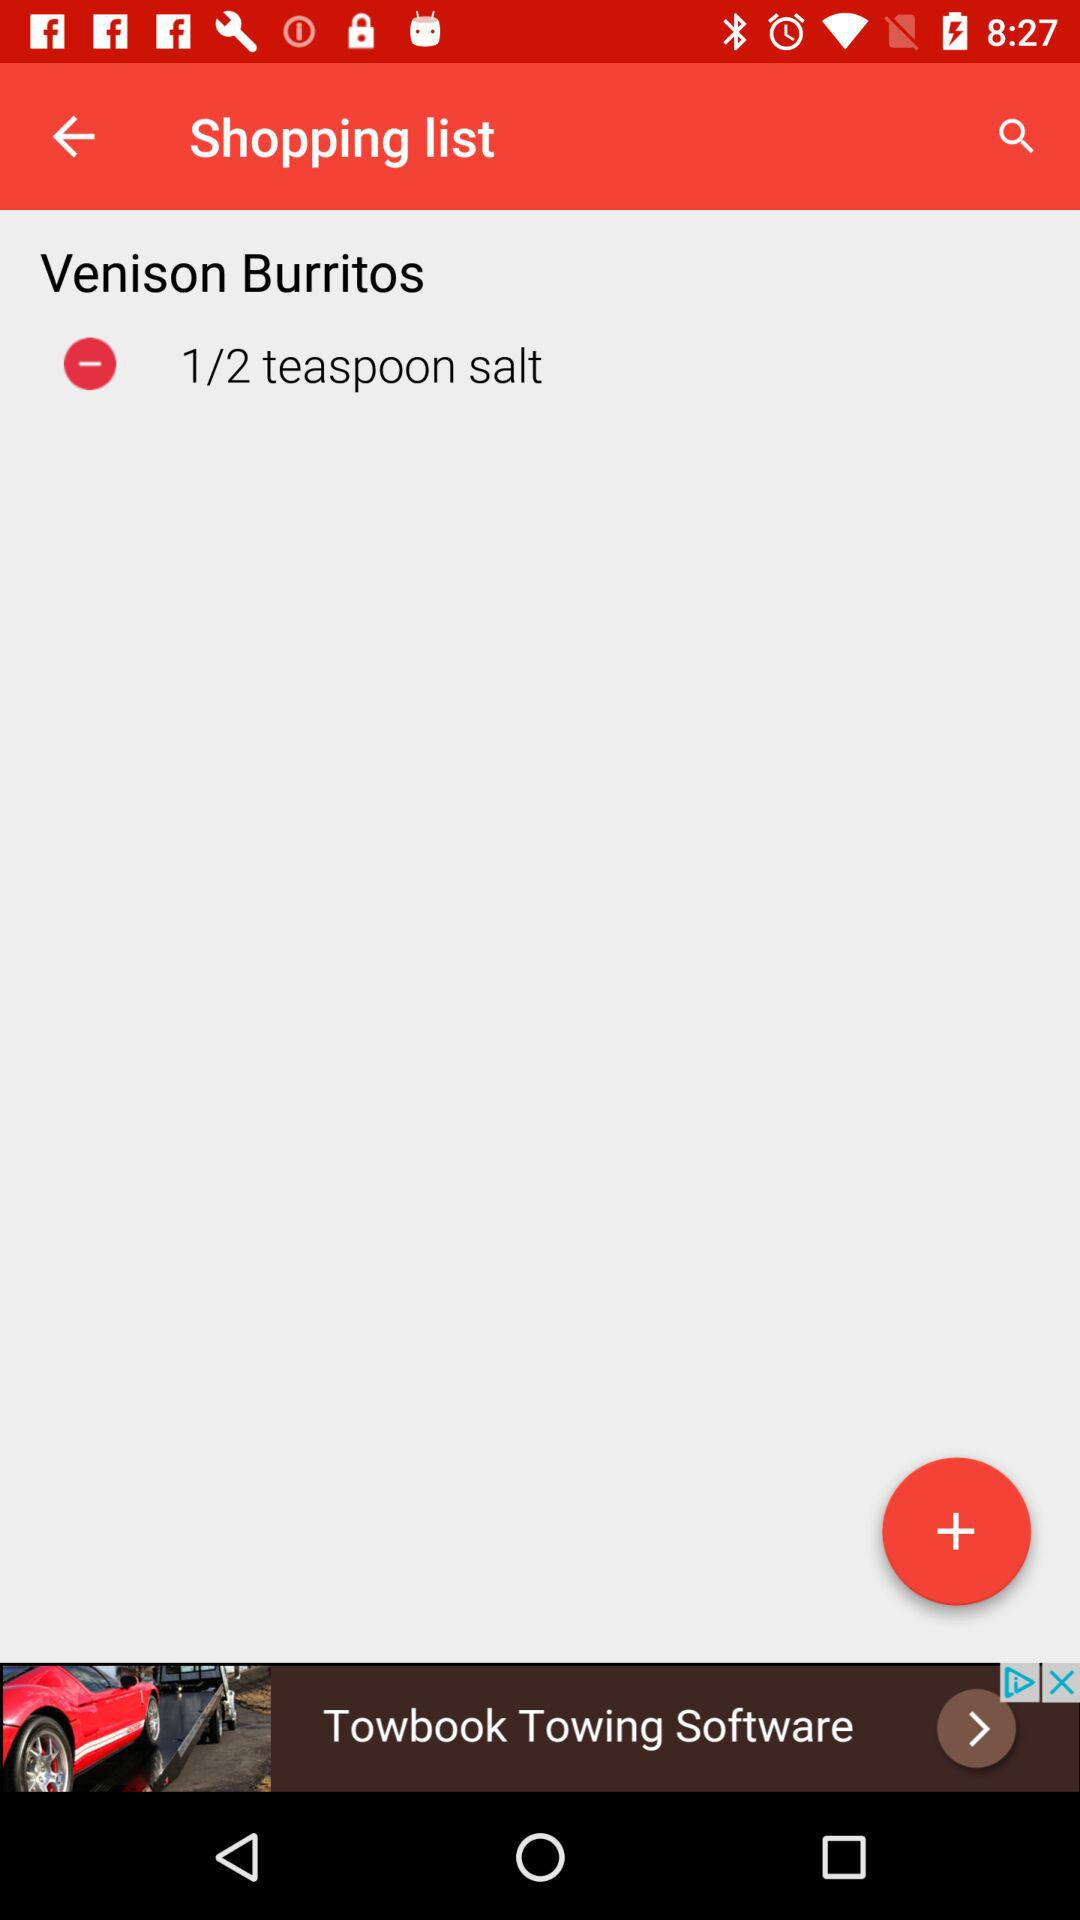How many teaspoons of salt are required for the Venison Burritos?
Answer the question using a single word or phrase. 1/2 